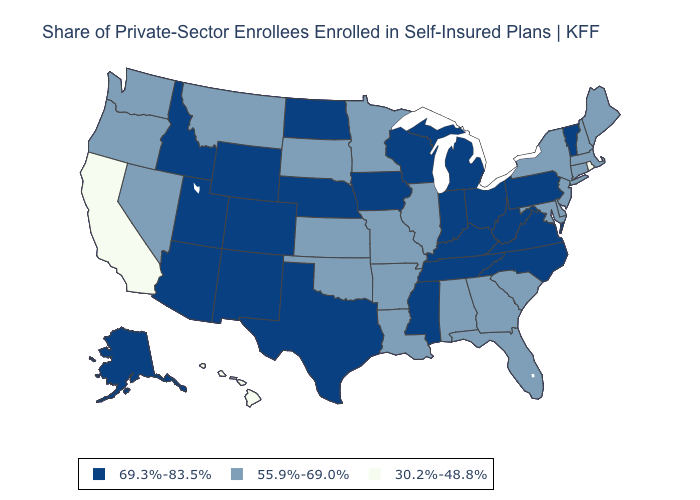Among the states that border Minnesota , which have the lowest value?
Answer briefly. South Dakota. What is the value of West Virginia?
Answer briefly. 69.3%-83.5%. Name the states that have a value in the range 69.3%-83.5%?
Write a very short answer. Alaska, Arizona, Colorado, Idaho, Indiana, Iowa, Kentucky, Michigan, Mississippi, Nebraska, New Mexico, North Carolina, North Dakota, Ohio, Pennsylvania, Tennessee, Texas, Utah, Vermont, Virginia, West Virginia, Wisconsin, Wyoming. Name the states that have a value in the range 69.3%-83.5%?
Quick response, please. Alaska, Arizona, Colorado, Idaho, Indiana, Iowa, Kentucky, Michigan, Mississippi, Nebraska, New Mexico, North Carolina, North Dakota, Ohio, Pennsylvania, Tennessee, Texas, Utah, Vermont, Virginia, West Virginia, Wisconsin, Wyoming. What is the lowest value in states that border Texas?
Concise answer only. 55.9%-69.0%. What is the value of Washington?
Be succinct. 55.9%-69.0%. What is the lowest value in the USA?
Answer briefly. 30.2%-48.8%. Name the states that have a value in the range 55.9%-69.0%?
Quick response, please. Alabama, Arkansas, Connecticut, Delaware, Florida, Georgia, Illinois, Kansas, Louisiana, Maine, Maryland, Massachusetts, Minnesota, Missouri, Montana, Nevada, New Hampshire, New Jersey, New York, Oklahoma, Oregon, South Carolina, South Dakota, Washington. Name the states that have a value in the range 30.2%-48.8%?
Give a very brief answer. California, Hawaii, Rhode Island. What is the value of Colorado?
Be succinct. 69.3%-83.5%. Name the states that have a value in the range 30.2%-48.8%?
Quick response, please. California, Hawaii, Rhode Island. Does Connecticut have a higher value than New York?
Answer briefly. No. What is the value of Delaware?
Concise answer only. 55.9%-69.0%. What is the lowest value in the Northeast?
Quick response, please. 30.2%-48.8%. Does Oregon have the highest value in the West?
Write a very short answer. No. 